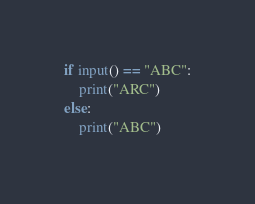Convert code to text. <code><loc_0><loc_0><loc_500><loc_500><_Python_>if input() == "ABC":
    print("ARC")
else:
    print("ABC")</code> 